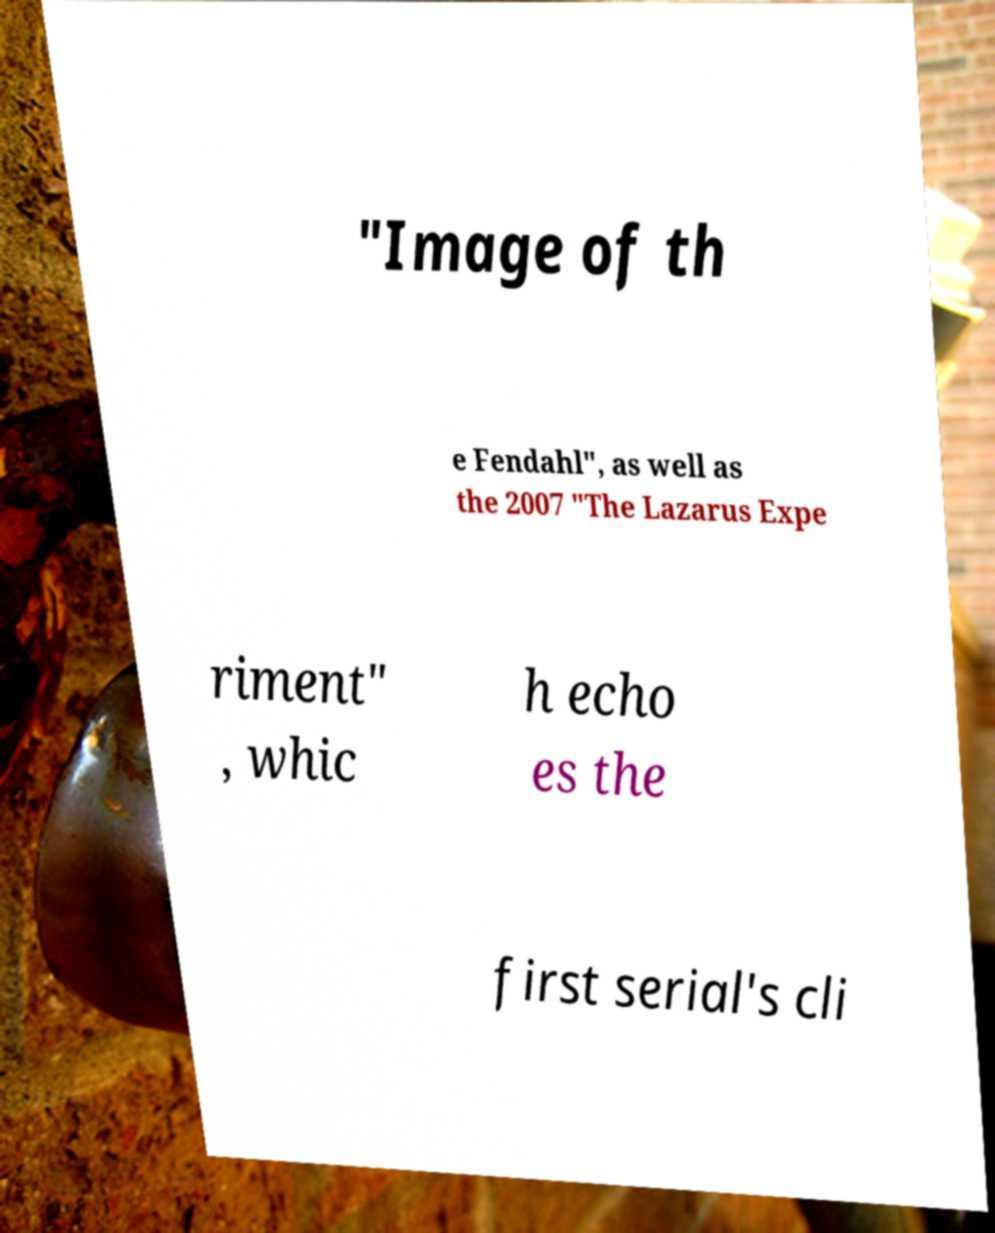What messages or text are displayed in this image? I need them in a readable, typed format. "Image of th e Fendahl", as well as the 2007 "The Lazarus Expe riment" , whic h echo es the first serial's cli 